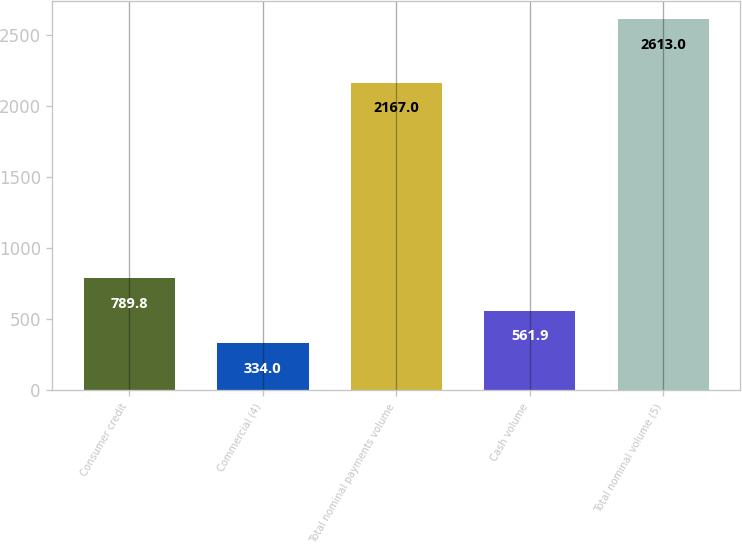<chart> <loc_0><loc_0><loc_500><loc_500><bar_chart><fcel>Consumer credit<fcel>Commercial (4)<fcel>Total nominal payments volume<fcel>Cash volume<fcel>Total nominal volume (5)<nl><fcel>789.8<fcel>334<fcel>2167<fcel>561.9<fcel>2613<nl></chart> 